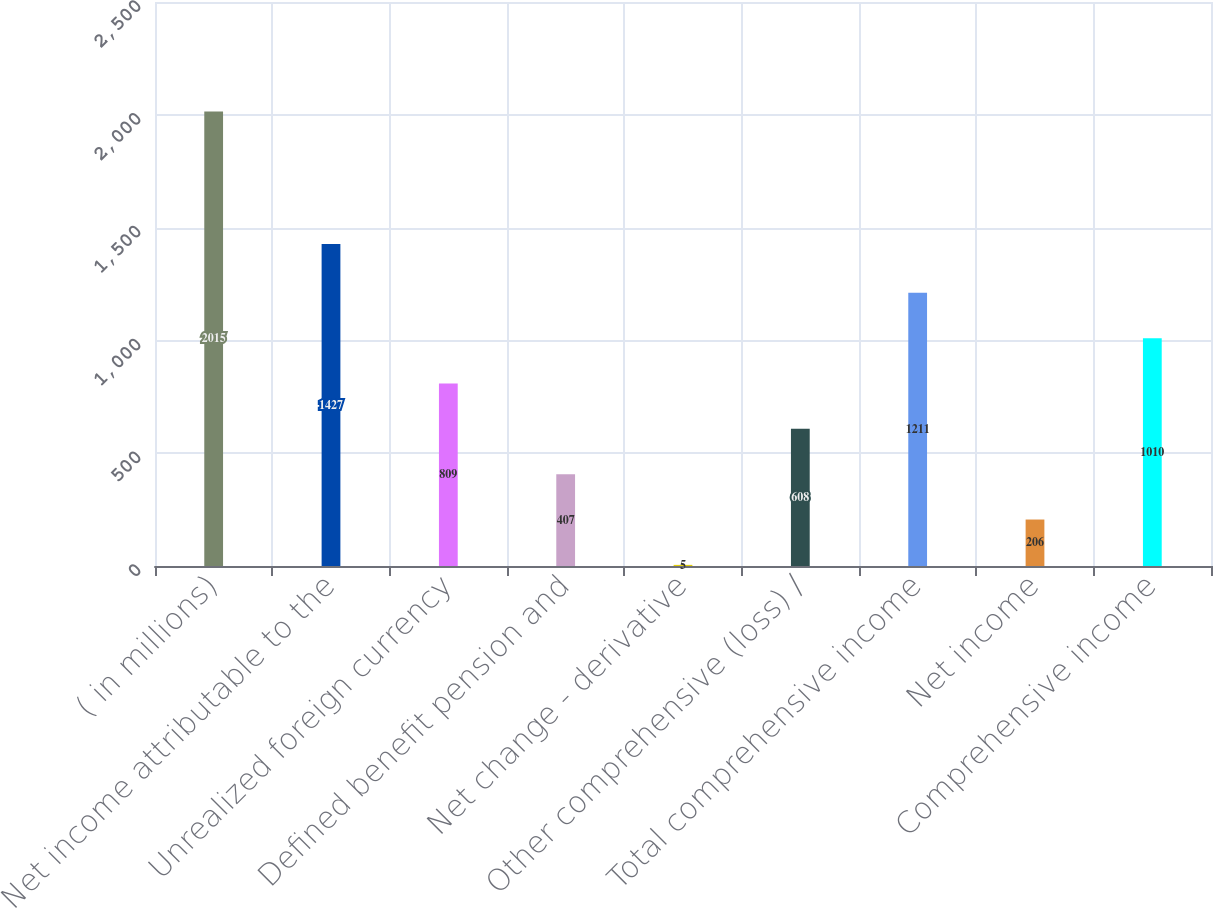Convert chart to OTSL. <chart><loc_0><loc_0><loc_500><loc_500><bar_chart><fcel>( in millions)<fcel>Net income attributable to the<fcel>Unrealized foreign currency<fcel>Defined benefit pension and<fcel>Net change - derivative<fcel>Other comprehensive (loss) /<fcel>Total comprehensive income<fcel>Net income<fcel>Comprehensive income<nl><fcel>2015<fcel>1427<fcel>809<fcel>407<fcel>5<fcel>608<fcel>1211<fcel>206<fcel>1010<nl></chart> 